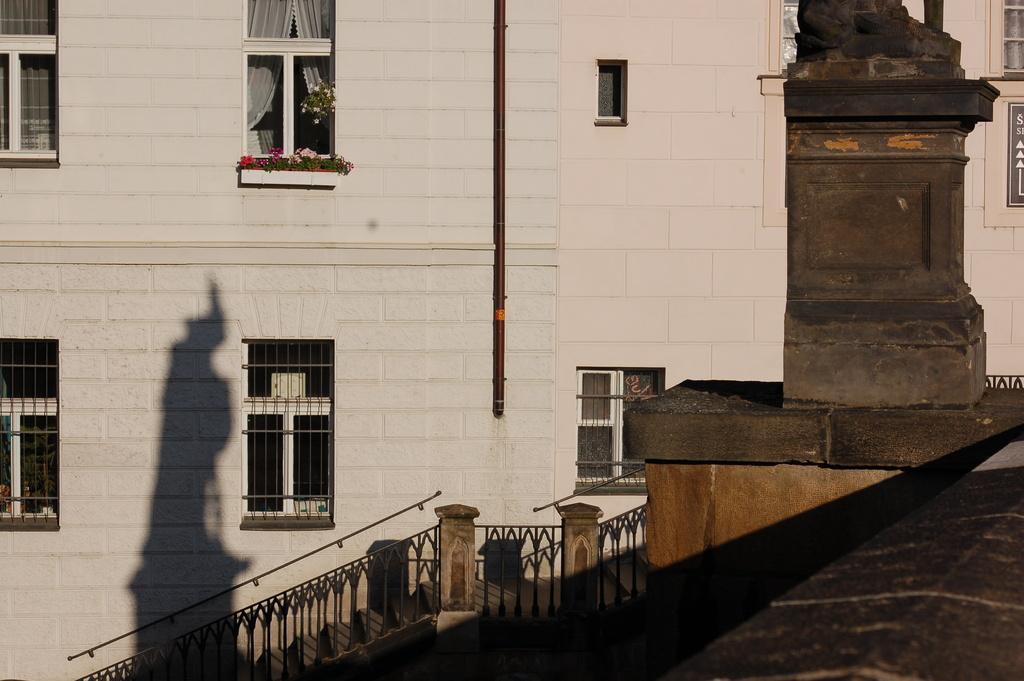In one or two sentences, can you explain what this image depicts? This picture shows buildings and we see stairs and few windows on the wall. 